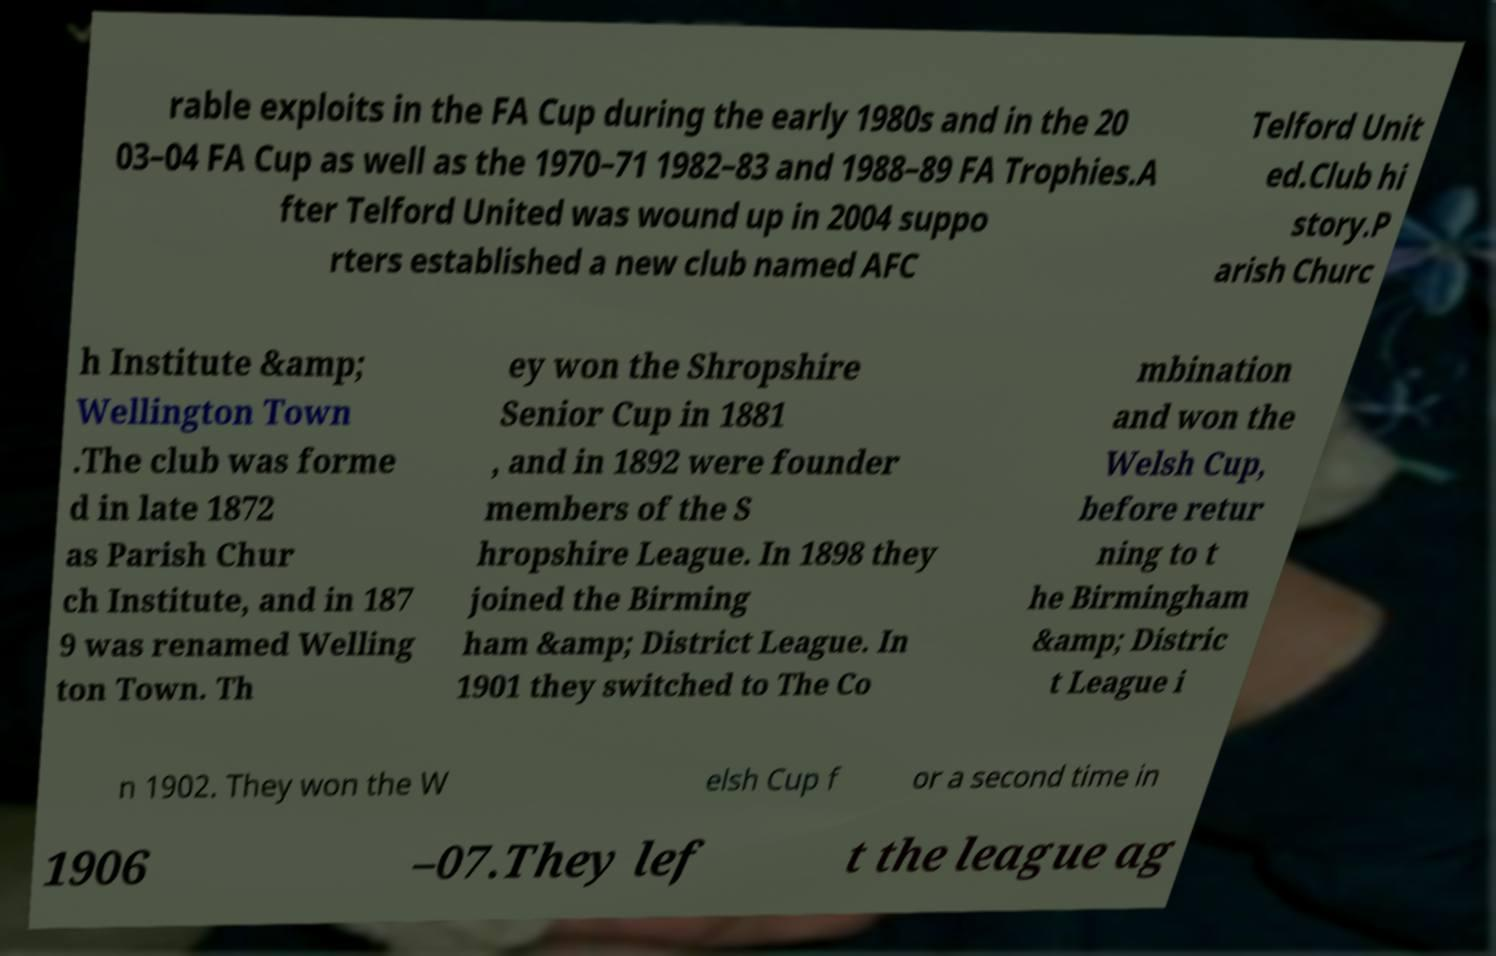Can you read and provide the text displayed in the image?This photo seems to have some interesting text. Can you extract and type it out for me? rable exploits in the FA Cup during the early 1980s and in the 20 03–04 FA Cup as well as the 1970–71 1982–83 and 1988–89 FA Trophies.A fter Telford United was wound up in 2004 suppo rters established a new club named AFC Telford Unit ed.Club hi story.P arish Churc h Institute &amp; Wellington Town .The club was forme d in late 1872 as Parish Chur ch Institute, and in 187 9 was renamed Welling ton Town. Th ey won the Shropshire Senior Cup in 1881 , and in 1892 were founder members of the S hropshire League. In 1898 they joined the Birming ham &amp; District League. In 1901 they switched to The Co mbination and won the Welsh Cup, before retur ning to t he Birmingham &amp; Distric t League i n 1902. They won the W elsh Cup f or a second time in 1906 –07.They lef t the league ag 